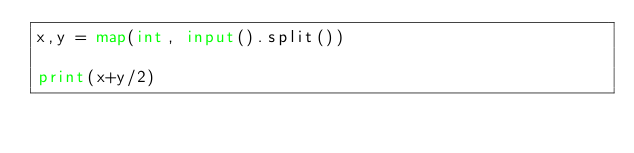<code> <loc_0><loc_0><loc_500><loc_500><_Python_>x,y = map(int, input().split())

print(x+y/2)</code> 